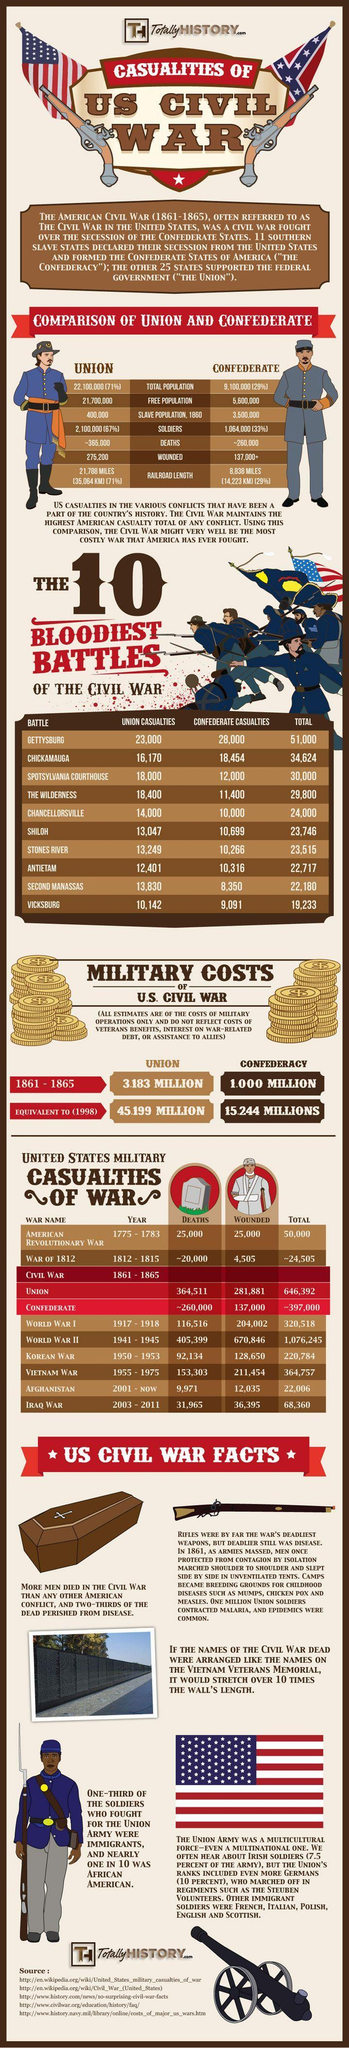List a handful of essential elements in this visual. The Second World War officially came to an end on January 2nd, 1945. During the Civil War, the free population in the Confederate States of America was approximately 5,600,000. The American Revolutionary War was the first war fought by the American people against foreign aggressors. According to historical records, during the Battle of Vicksburg in the American Civil War, a total of 9,091 Confederate casualties were reported. The total number of casualties reported in the Battle of Gettysburg is 51,000. 